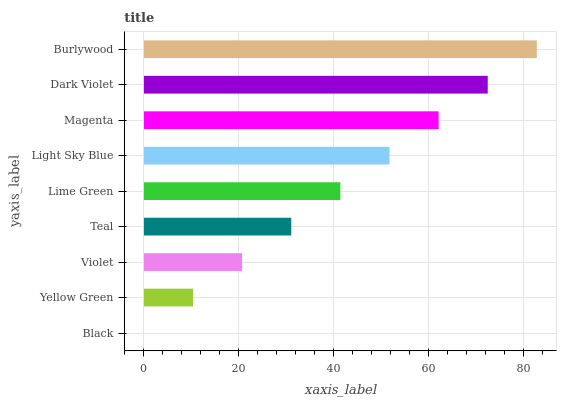Is Black the minimum?
Answer yes or no. Yes. Is Burlywood the maximum?
Answer yes or no. Yes. Is Yellow Green the minimum?
Answer yes or no. No. Is Yellow Green the maximum?
Answer yes or no. No. Is Yellow Green greater than Black?
Answer yes or no. Yes. Is Black less than Yellow Green?
Answer yes or no. Yes. Is Black greater than Yellow Green?
Answer yes or no. No. Is Yellow Green less than Black?
Answer yes or no. No. Is Lime Green the high median?
Answer yes or no. Yes. Is Lime Green the low median?
Answer yes or no. Yes. Is Burlywood the high median?
Answer yes or no. No. Is Violet the low median?
Answer yes or no. No. 